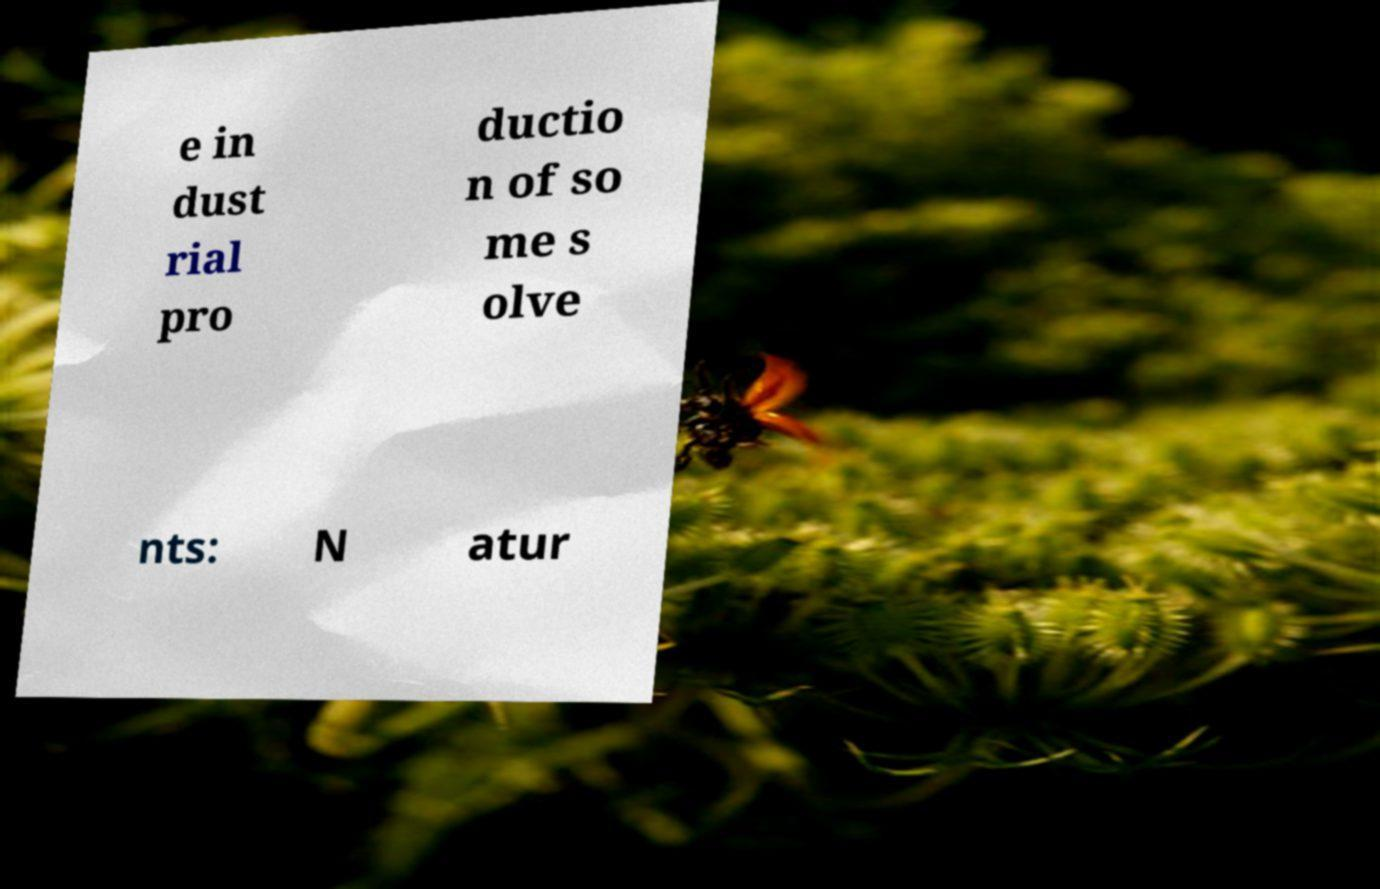Could you assist in decoding the text presented in this image and type it out clearly? e in dust rial pro ductio n of so me s olve nts: N atur 